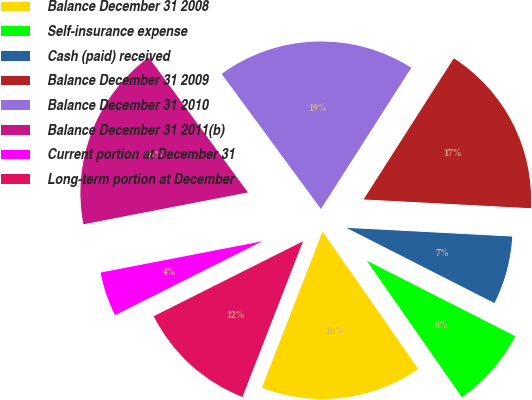Convert chart. <chart><loc_0><loc_0><loc_500><loc_500><pie_chart><fcel>Balance December 31 2008<fcel>Self-insurance expense<fcel>Cash (paid) received<fcel>Balance December 31 2009<fcel>Balance December 31 2010<fcel>Balance December 31 2011(b)<fcel>Current portion at December 31<fcel>Long-term portion at December<nl><fcel>15.59%<fcel>7.83%<fcel>6.65%<fcel>16.78%<fcel>19.14%<fcel>17.96%<fcel>4.36%<fcel>11.69%<nl></chart> 